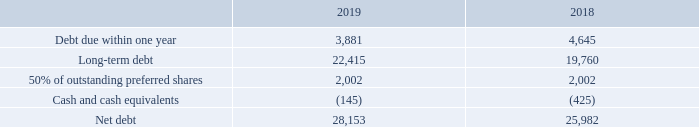NET DEBT
The term net debt does not have any standardized meaning under IFRS. Therefore, it is unlikely to be comparable to similar measures presented by other issuers.
We define net debt as debt due within one year plus long-term debt and 50% of preferred shares, less cash and cash equivalents, as shown in BCE’s consolidated statements of financial position. We include 50% of outstanding preferred shares in our net debt as it is consistent with the treatment by certain credit rating agencies.
We consider net debt to be an important indicator of the company’s financial leverage because it represents the amount of debt that is not covered by available cash and cash equivalents. We believe that certain investors and analysts use net debt to determine a company’s financial leverage.
Net debt has no directly comparable IFRS financial measure, but rather is calculated using several asset and liability categories from the statements of financial position, as shown in the following table.
How is net debt defined? Debt due within one year plus long-term debt and 50% of preferred shares, less cash and cash equivalents, as shown in bce’s consolidated statements of financial position. Why is net debt considered as an important indicator of the company's financial leverage? Because it represents the amount of debt that is not covered by available cash and cash equivalents. What is the Debt due within one year for 2019? 3,881. What is the change in the debt due within one year in 2019? 3,881-4,645
Answer: -764. What is the percentage change in long-term debt in 2019?
Answer scale should be: percent. (22,415-19,760)/19,760
Answer: 13.44. What is the change in net debt in 2019? 28,153-25,982
Answer: 2171. 